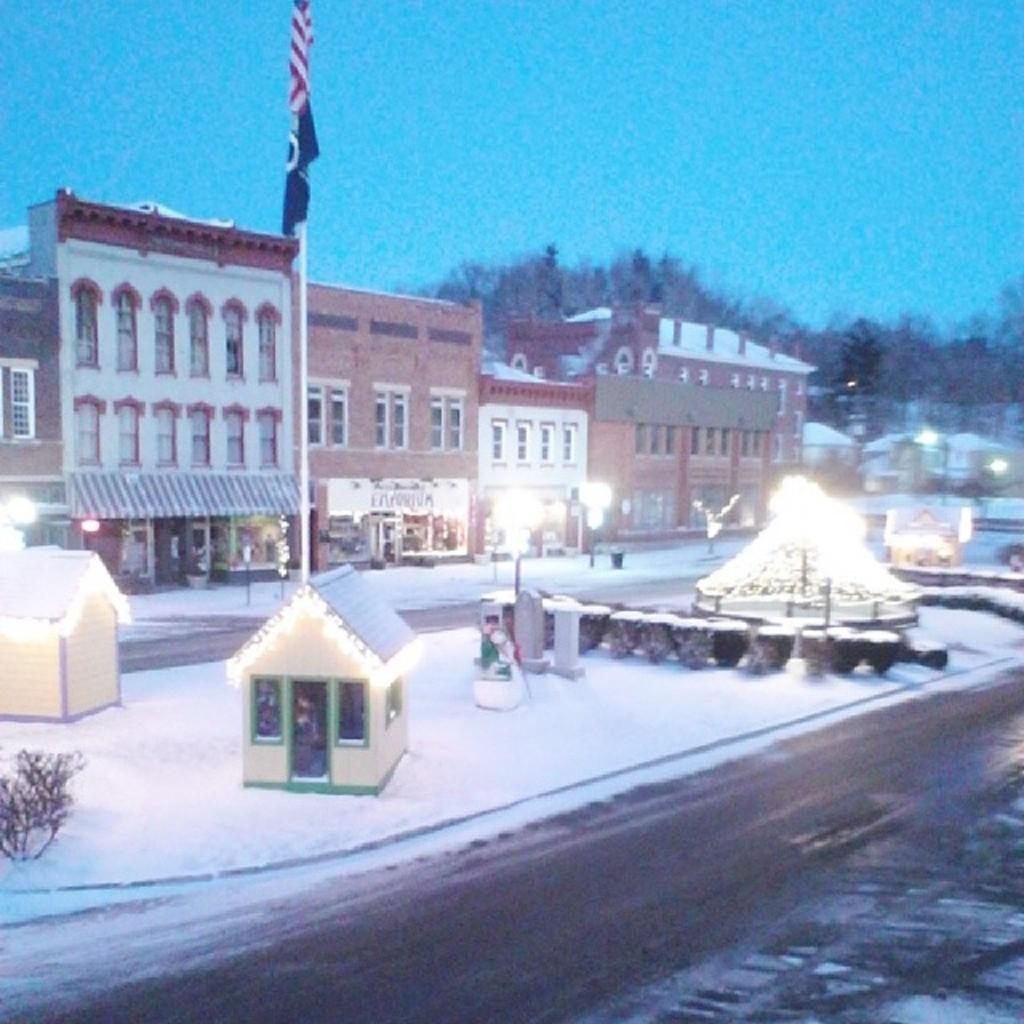What type of structures can be seen in the image? There are houses in the image. What type of vegetation is present in the image? There are trees in the image. What weather condition is depicted in the image? There is snow visible in the image. What type of illumination is present in the image? There are lights in the image. What type of support structures are visible in the image? There are poles in the image. What type of decorative elements are present in the image? There are flags in the image. What type of pathway is visible in the image? There is a road in the image. What can be seen in the background of the image? The sky is visible in the background of the image. What type of jewel can be seen on the road in the image? There is no jewel present on the road in the image. How far away is the mist visible from the houses in the image? There is no mist visible in the image. 